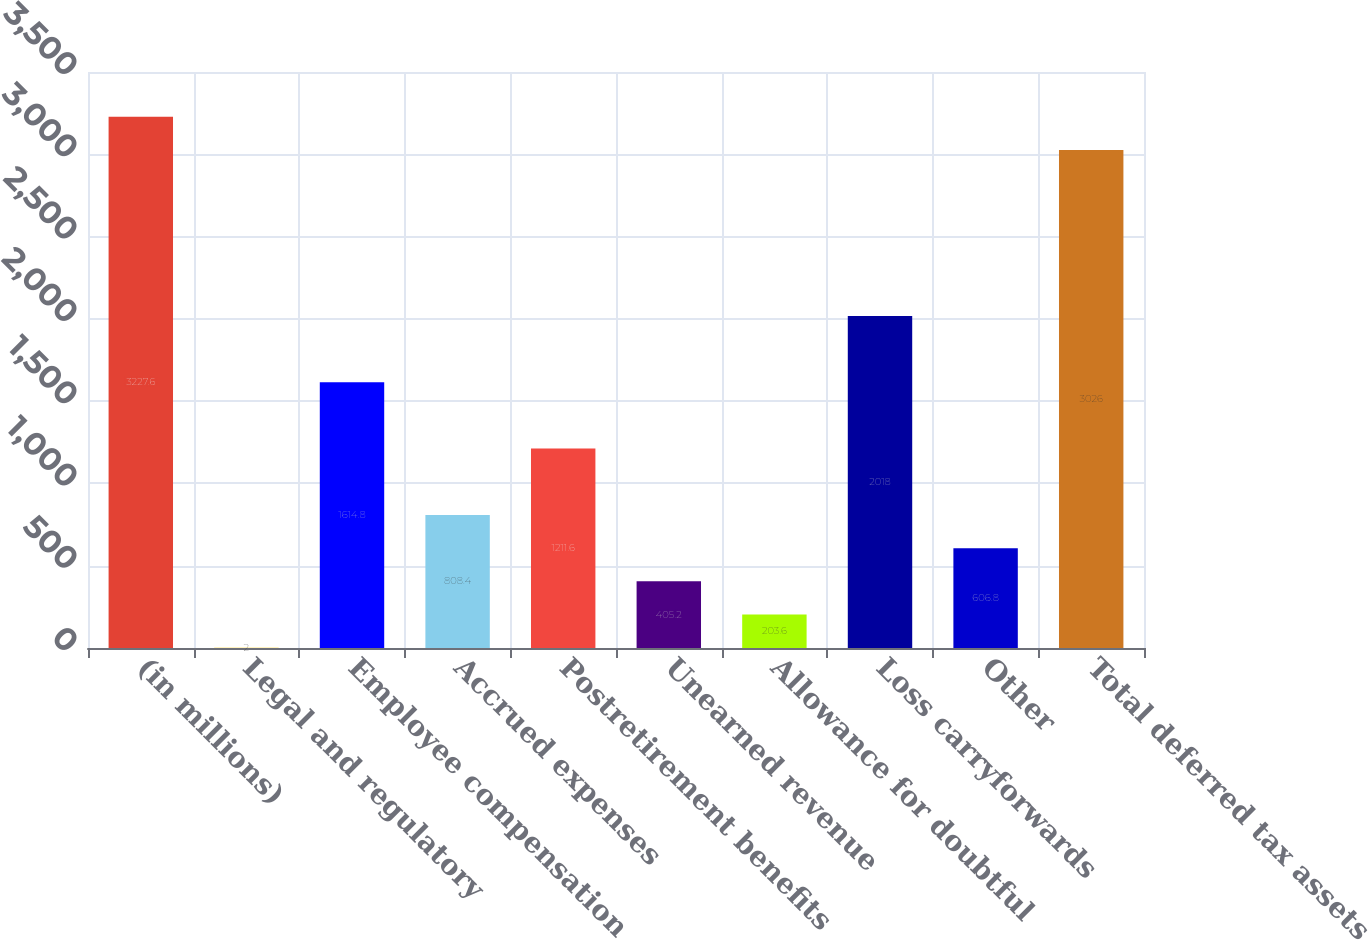<chart> <loc_0><loc_0><loc_500><loc_500><bar_chart><fcel>(in millions)<fcel>Legal and regulatory<fcel>Employee compensation<fcel>Accrued expenses<fcel>Postretirement benefits<fcel>Unearned revenue<fcel>Allowance for doubtful<fcel>Loss carryforwards<fcel>Other<fcel>Total deferred tax assets<nl><fcel>3227.6<fcel>2<fcel>1614.8<fcel>808.4<fcel>1211.6<fcel>405.2<fcel>203.6<fcel>2018<fcel>606.8<fcel>3026<nl></chart> 